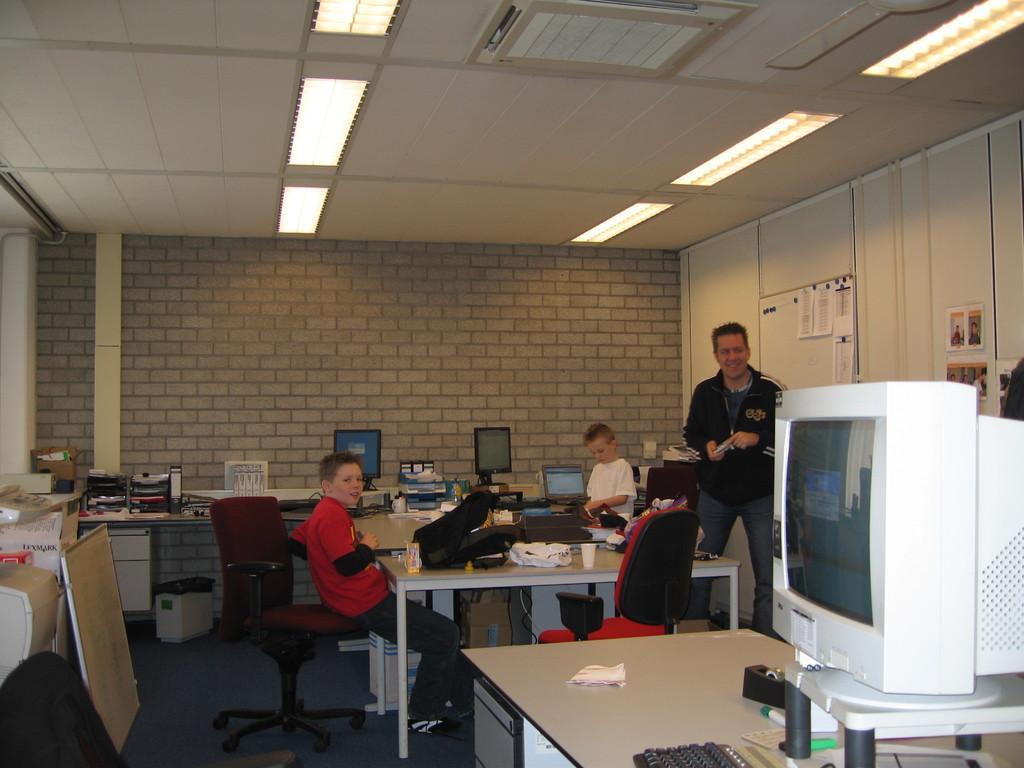In one or two sentences, can you explain what this image depicts? In the image we can see there are people who are sitting on chair and few people are standing and on table there are backpack, monitor, keyboard, laptops, file, glass, cover and on the top there are tube lights and centralised AC and the wall is made up of bricks. 